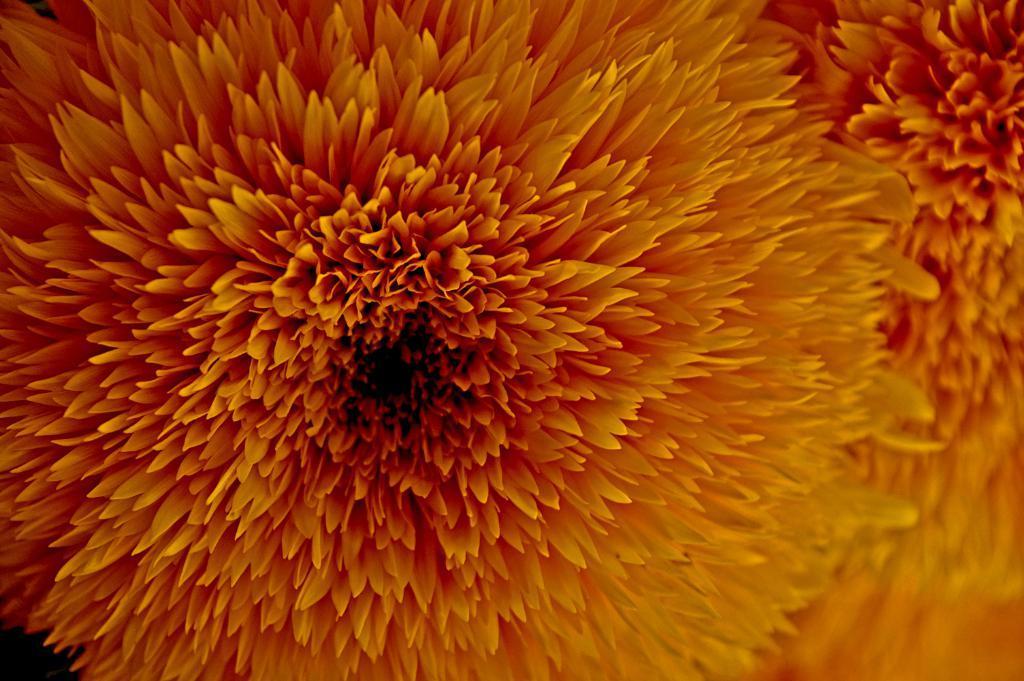Can you describe this image briefly? This is a zoomed in picture. In the center we can see the flower and the petals of the flower. 